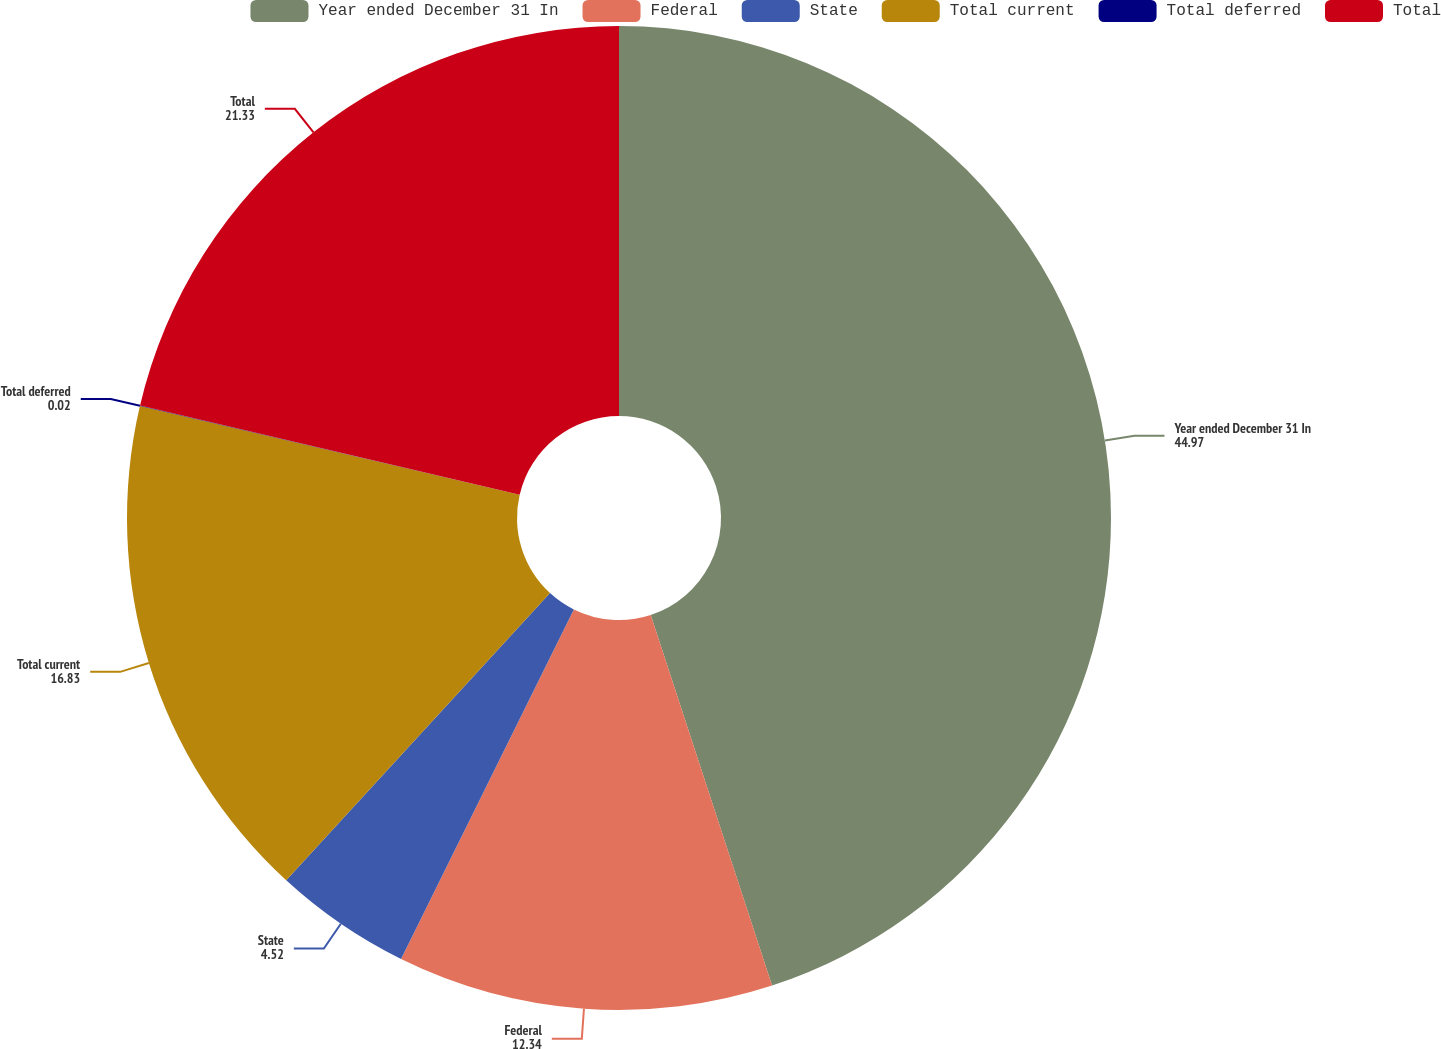Convert chart. <chart><loc_0><loc_0><loc_500><loc_500><pie_chart><fcel>Year ended December 31 In<fcel>Federal<fcel>State<fcel>Total current<fcel>Total deferred<fcel>Total<nl><fcel>44.97%<fcel>12.34%<fcel>4.52%<fcel>16.83%<fcel>0.02%<fcel>21.33%<nl></chart> 